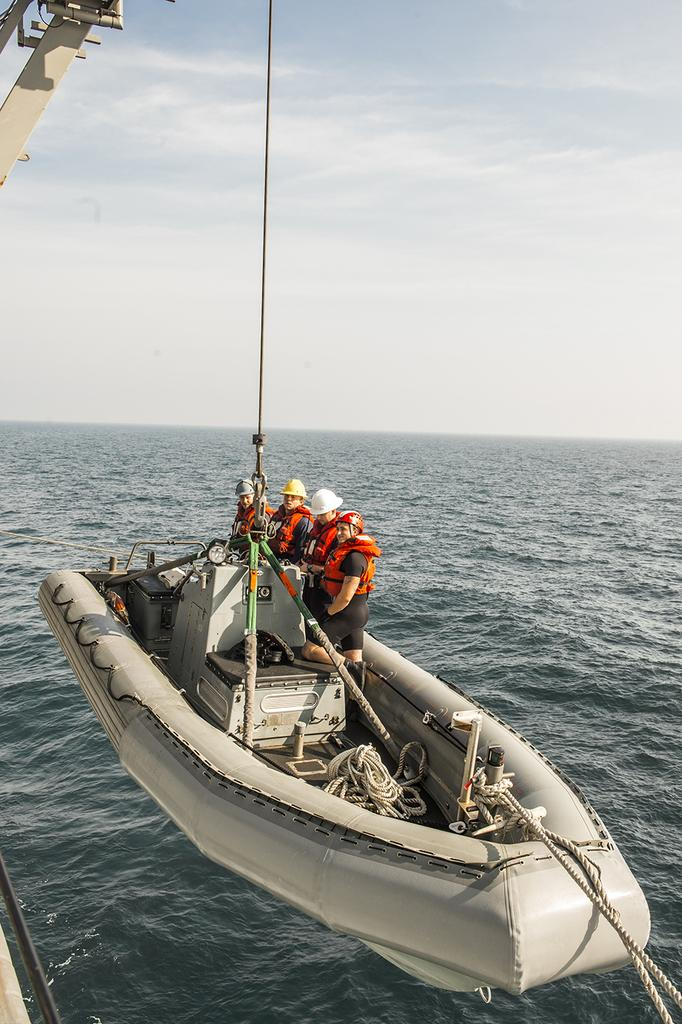What is the main subject of the image? The main subject of the image is a boat. What is the boat's current state or position? The boat is hanging from a crane. How many people are in the boat? There are four members in the boat. What safety equipment are the members wearing? The members are wearing life jackets and helmets. What can be seen in the background of the image? There is an ocean and the sky visible in the background of the image. What type of beetle can be seen crawling on the boat in the image? There is no beetle present on the boat in the image. What is the current account balance of the members in the boat? There is no information about the members' account balances in the image. 